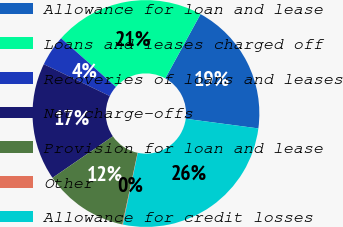<chart> <loc_0><loc_0><loc_500><loc_500><pie_chart><fcel>Allowance for loan and lease<fcel>Loans and leases charged off<fcel>Recoveries of loans and leases<fcel>Net charge-offs<fcel>Provision for loan and lease<fcel>Other<fcel>Allowance for credit losses<nl><fcel>19.1%<fcel>21.45%<fcel>4.39%<fcel>16.75%<fcel>12.07%<fcel>0.08%<fcel>26.16%<nl></chart> 